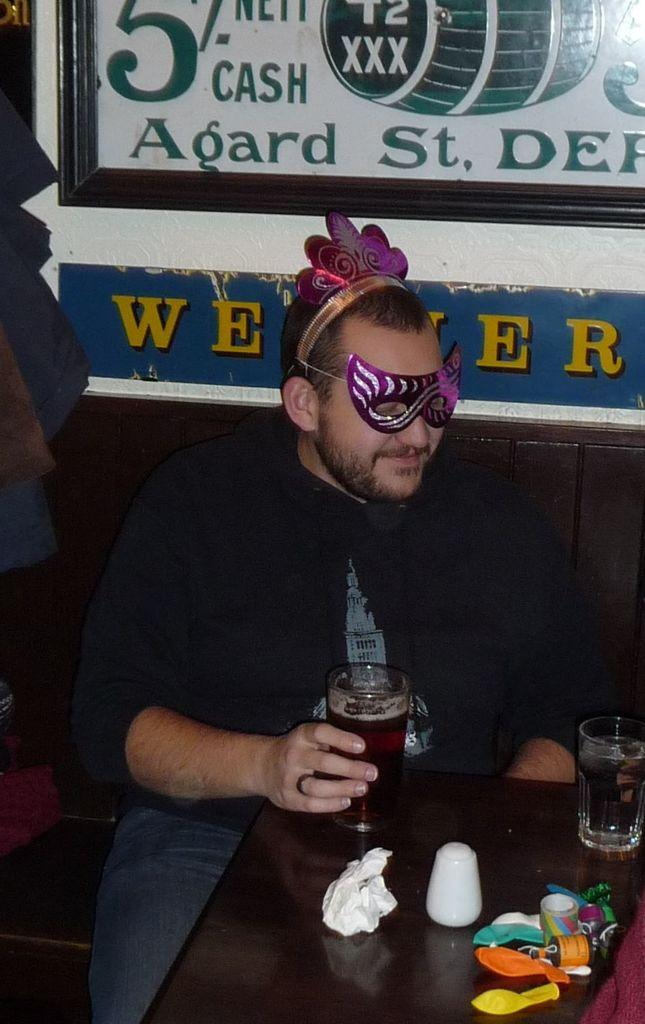What is the man in the image wearing on his face? The man is wearing an eye mask. What is the man holding in his hands? The man is holding a glass in his hands. What decorative items can be seen in the image? There are balloons in the image. What items related to recording or attaching can be seen in the image? There are tapes in the image. What items related to writing or documentation can be seen in the image? There are papers in the image. Where is another glass located in the image? There is a glass on the table in the image. What type of shirt is the toy wearing in the image? There is no toy present in the image, and therefore no shirt to describe. 